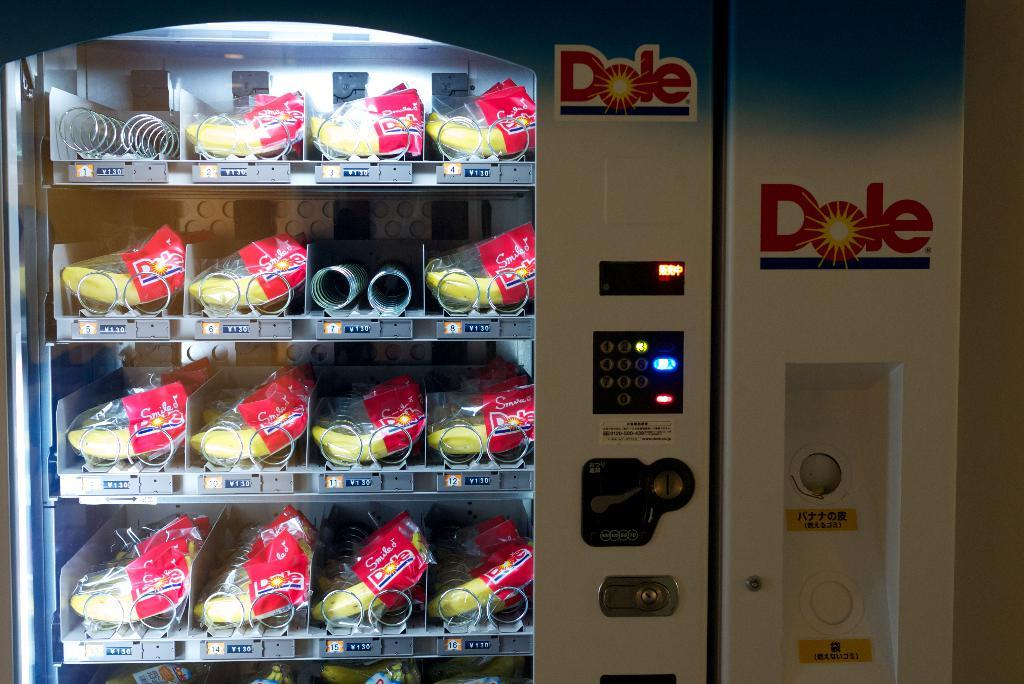<image>
Give a short and clear explanation of the subsequent image. A Dole fruit vending machine with bananas inside the machine. 